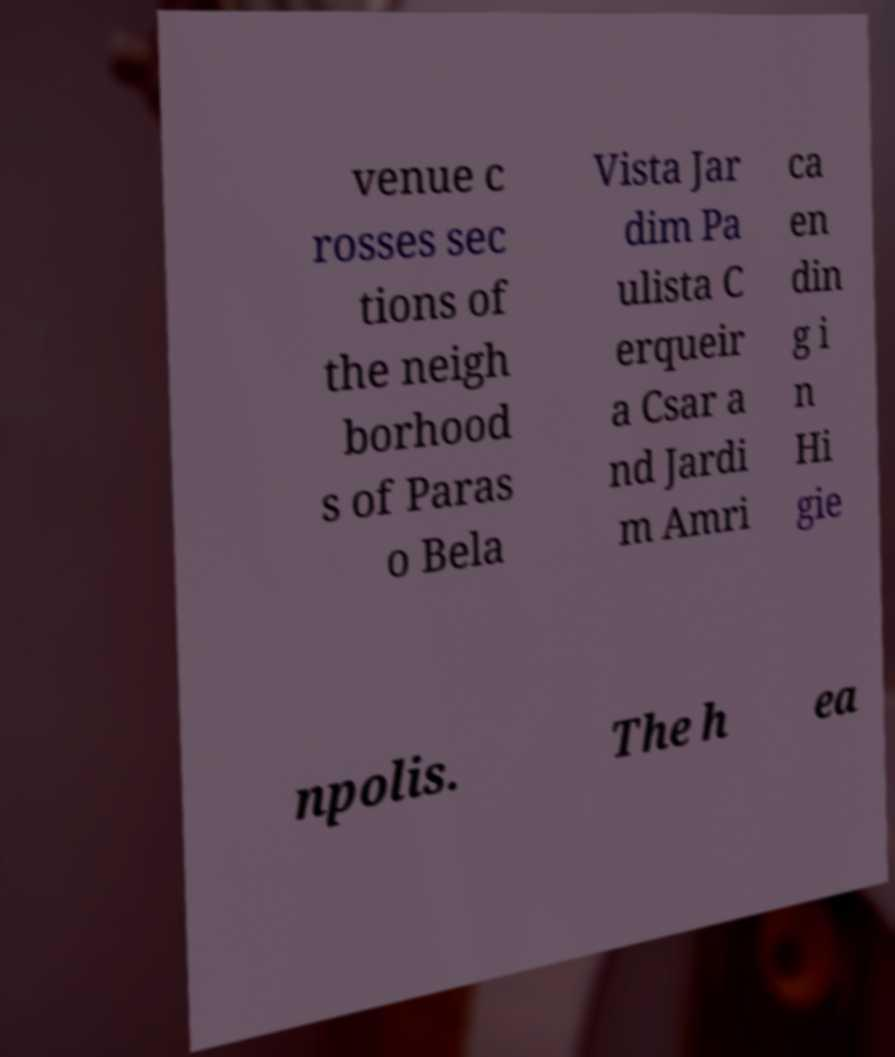Can you read and provide the text displayed in the image?This photo seems to have some interesting text. Can you extract and type it out for me? venue c rosses sec tions of the neigh borhood s of Paras o Bela Vista Jar dim Pa ulista C erqueir a Csar a nd Jardi m Amri ca en din g i n Hi gie npolis. The h ea 